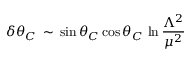<formula> <loc_0><loc_0><loc_500><loc_500>\delta \theta _ { C } \, \sim \, \sin \theta _ { C } \cos \theta _ { C } \, \ln \frac { \Lambda ^ { 2 } } { \mu ^ { 2 } }</formula> 